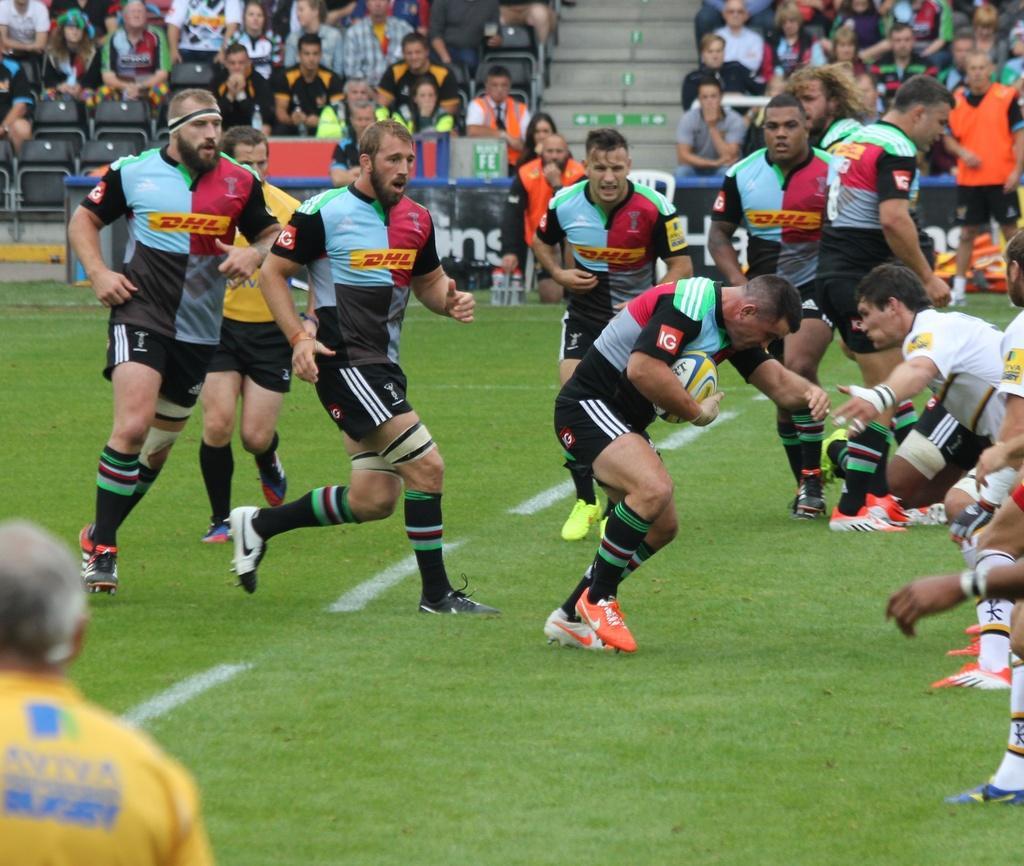Describe this image in one or two sentences. In this picture I can see a group of people are playing the game in the middle, in the background a group of people are sitting on the chairs and watching this game. 